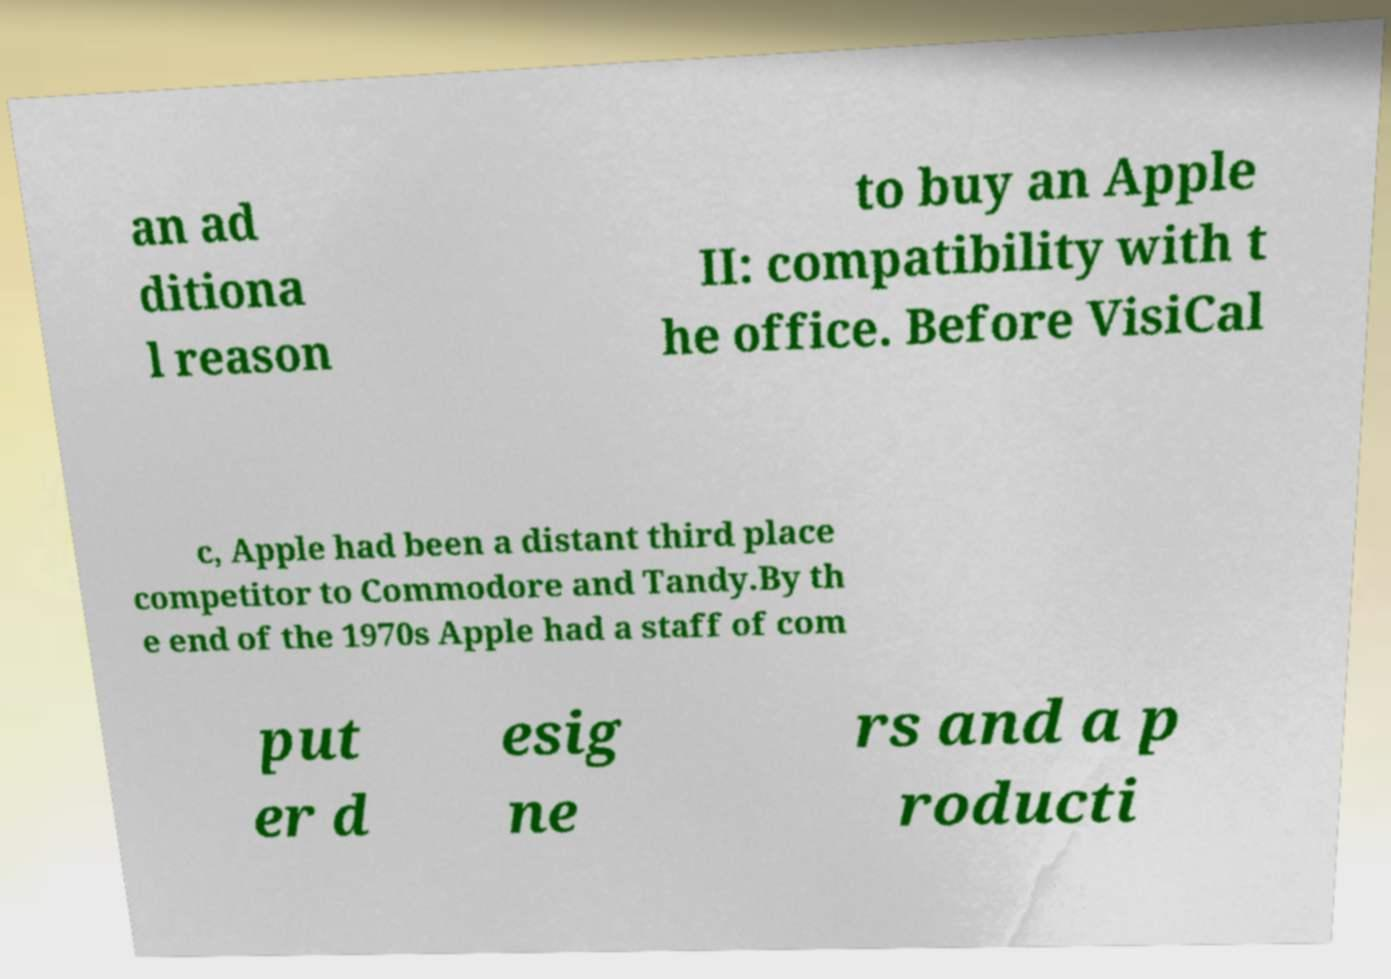Can you accurately transcribe the text from the provided image for me? an ad ditiona l reason to buy an Apple II: compatibility with t he office. Before VisiCal c, Apple had been a distant third place competitor to Commodore and Tandy.By th e end of the 1970s Apple had a staff of com put er d esig ne rs and a p roducti 